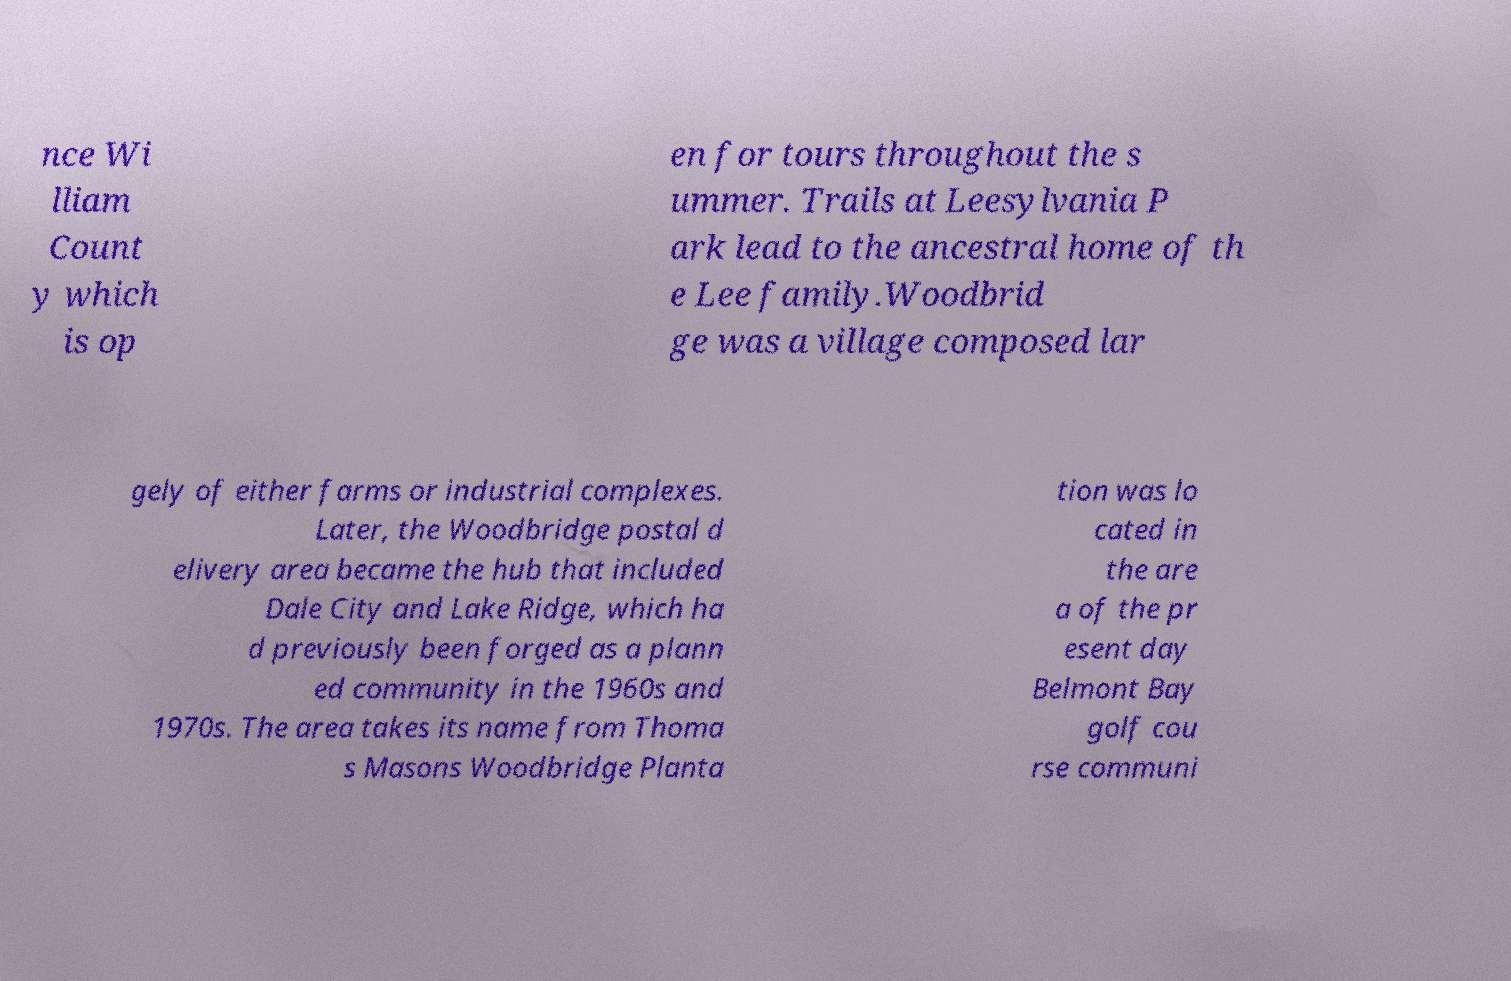Could you extract and type out the text from this image? nce Wi lliam Count y which is op en for tours throughout the s ummer. Trails at Leesylvania P ark lead to the ancestral home of th e Lee family.Woodbrid ge was a village composed lar gely of either farms or industrial complexes. Later, the Woodbridge postal d elivery area became the hub that included Dale City and Lake Ridge, which ha d previously been forged as a plann ed community in the 1960s and 1970s. The area takes its name from Thoma s Masons Woodbridge Planta tion was lo cated in the are a of the pr esent day Belmont Bay golf cou rse communi 